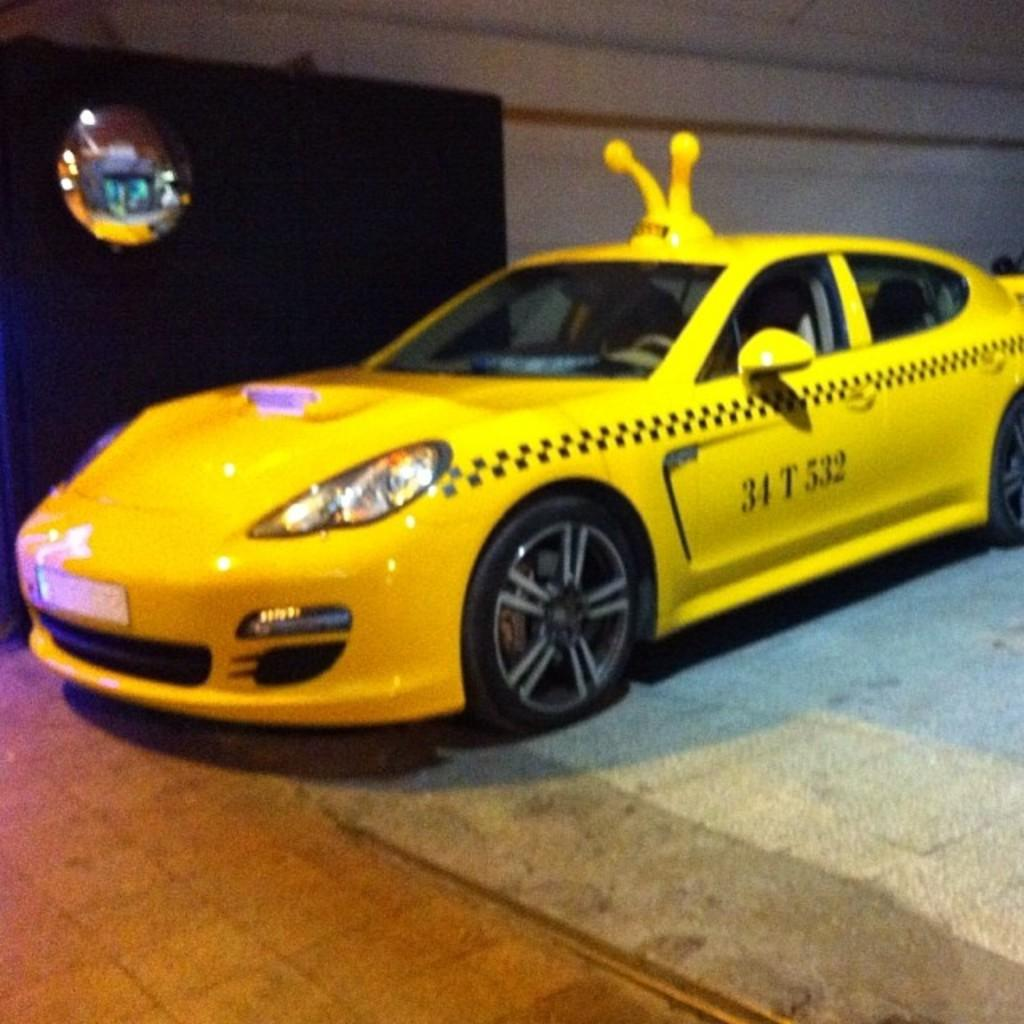<image>
Give a short and clear explanation of the subsequent image. a car with the number 34 on the side of it 